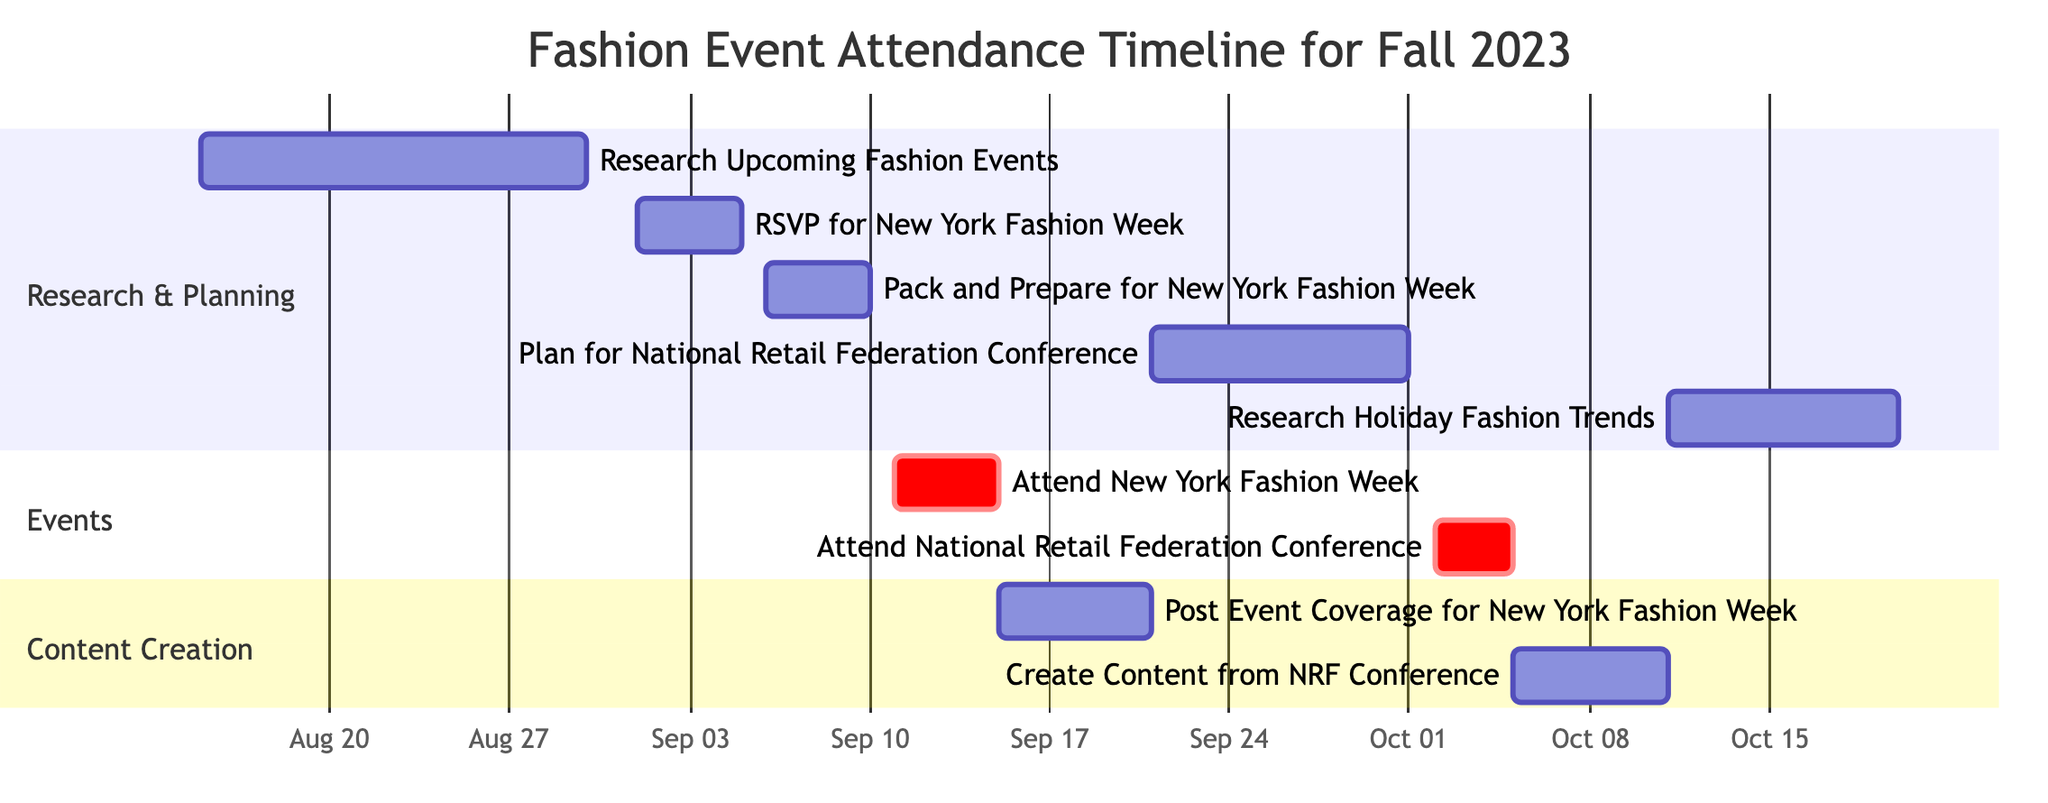What's the start date for the "Attend New York Fashion Week" task? The "Attend New York Fashion Week" task begins on September 11, 2023. This date is listed directly in the Gantt chart.
Answer: September 11 How many days does the "Post Event Coverage for New York Fashion Week" task last? The "Post Event Coverage for New York Fashion Week" starts on September 15, 2023, and ends on September 20, 2023. Counting the days, it lasts for 6 days.
Answer: 6 days What is the end date for the "Attend National Retail Federation Conference"? The "Attend National Retail Federation Conference" task ends on October 4, 2023. This date can be found in the Gantt chart under the Events section.
Answer: October 4 Which task overlaps with "Pack and Prepare for New York Fashion Week"? The "Pack and Prepare for New York Fashion Week" task overlaps with the "RSVP for New York Fashion Week" task, as it runs from September 6 to September 10 while the RSVP task runs from September 1 to September 5.
Answer: RSVP for New York Fashion Week How many tasks are scheduled in the Events section? There are a total of 2 tasks scheduled in the Events section: "Attend New York Fashion Week" and "Attend National Retail Federation Conference." This can be counted directly from the diagram's Events section.
Answer: 2 tasks What is the duration of the "Plan for National Retail Federation Conference" task? The "Plan for National Retail Federation Conference" starts on September 21, 2023, and ends on October 1, 2023. Counting these dates gives a total duration of 11 days.
Answer: 11 days What task comes immediately after "Attend New York Fashion Week"? The task that comes immediately after "Attend New York Fashion Week" is "Post Event Coverage for New York Fashion Week," which starts on September 15, right after the previous task ends on September 14.
Answer: Post Event Coverage for New York Fashion Week Which task is scheduled first in the Content Creation section? The first task in the Content Creation section is "Post Event Coverage for New York Fashion Week," which starts on September 15, 2023.
Answer: Post Event Coverage for New York Fashion Week 